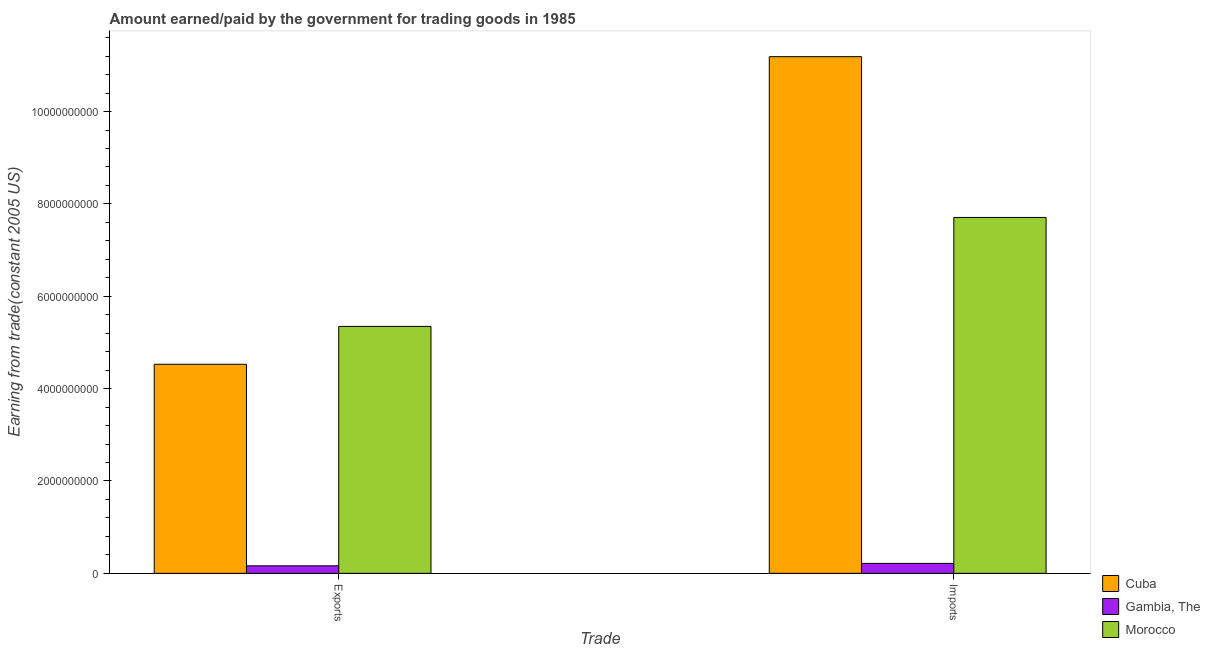How many different coloured bars are there?
Your answer should be compact. 3. Are the number of bars per tick equal to the number of legend labels?
Keep it short and to the point. Yes. Are the number of bars on each tick of the X-axis equal?
Your answer should be compact. Yes. How many bars are there on the 1st tick from the right?
Your answer should be compact. 3. What is the label of the 1st group of bars from the left?
Your response must be concise. Exports. What is the amount paid for imports in Gambia, The?
Keep it short and to the point. 2.15e+08. Across all countries, what is the maximum amount earned from exports?
Provide a short and direct response. 5.35e+09. Across all countries, what is the minimum amount earned from exports?
Your answer should be very brief. 1.63e+08. In which country was the amount earned from exports maximum?
Your answer should be very brief. Morocco. In which country was the amount earned from exports minimum?
Your answer should be compact. Gambia, The. What is the total amount paid for imports in the graph?
Give a very brief answer. 1.91e+1. What is the difference between the amount earned from exports in Cuba and that in Gambia, The?
Provide a short and direct response. 4.36e+09. What is the difference between the amount earned from exports in Cuba and the amount paid for imports in Gambia, The?
Keep it short and to the point. 4.31e+09. What is the average amount paid for imports per country?
Make the answer very short. 6.37e+09. What is the difference between the amount earned from exports and amount paid for imports in Gambia, The?
Offer a terse response. -5.21e+07. In how many countries, is the amount paid for imports greater than 8400000000 US$?
Offer a very short reply. 1. What is the ratio of the amount earned from exports in Cuba to that in Morocco?
Give a very brief answer. 0.85. In how many countries, is the amount earned from exports greater than the average amount earned from exports taken over all countries?
Offer a terse response. 2. What does the 3rd bar from the left in Imports represents?
Make the answer very short. Morocco. What does the 3rd bar from the right in Imports represents?
Provide a succinct answer. Cuba. Are all the bars in the graph horizontal?
Provide a short and direct response. No. Where does the legend appear in the graph?
Offer a terse response. Bottom right. How many legend labels are there?
Keep it short and to the point. 3. What is the title of the graph?
Provide a short and direct response. Amount earned/paid by the government for trading goods in 1985. What is the label or title of the X-axis?
Keep it short and to the point. Trade. What is the label or title of the Y-axis?
Ensure brevity in your answer.  Earning from trade(constant 2005 US). What is the Earning from trade(constant 2005 US) in Cuba in Exports?
Your response must be concise. 4.53e+09. What is the Earning from trade(constant 2005 US) in Gambia, The in Exports?
Keep it short and to the point. 1.63e+08. What is the Earning from trade(constant 2005 US) of Morocco in Exports?
Keep it short and to the point. 5.35e+09. What is the Earning from trade(constant 2005 US) in Cuba in Imports?
Make the answer very short. 1.12e+1. What is the Earning from trade(constant 2005 US) of Gambia, The in Imports?
Make the answer very short. 2.15e+08. What is the Earning from trade(constant 2005 US) in Morocco in Imports?
Provide a succinct answer. 7.71e+09. Across all Trade, what is the maximum Earning from trade(constant 2005 US) of Cuba?
Your answer should be very brief. 1.12e+1. Across all Trade, what is the maximum Earning from trade(constant 2005 US) of Gambia, The?
Provide a succinct answer. 2.15e+08. Across all Trade, what is the maximum Earning from trade(constant 2005 US) of Morocco?
Make the answer very short. 7.71e+09. Across all Trade, what is the minimum Earning from trade(constant 2005 US) in Cuba?
Keep it short and to the point. 4.53e+09. Across all Trade, what is the minimum Earning from trade(constant 2005 US) in Gambia, The?
Offer a very short reply. 1.63e+08. Across all Trade, what is the minimum Earning from trade(constant 2005 US) in Morocco?
Your answer should be very brief. 5.35e+09. What is the total Earning from trade(constant 2005 US) of Cuba in the graph?
Ensure brevity in your answer.  1.57e+1. What is the total Earning from trade(constant 2005 US) in Gambia, The in the graph?
Offer a very short reply. 3.78e+08. What is the total Earning from trade(constant 2005 US) in Morocco in the graph?
Provide a short and direct response. 1.31e+1. What is the difference between the Earning from trade(constant 2005 US) of Cuba in Exports and that in Imports?
Your answer should be very brief. -6.66e+09. What is the difference between the Earning from trade(constant 2005 US) in Gambia, The in Exports and that in Imports?
Make the answer very short. -5.21e+07. What is the difference between the Earning from trade(constant 2005 US) in Morocco in Exports and that in Imports?
Provide a succinct answer. -2.36e+09. What is the difference between the Earning from trade(constant 2005 US) in Cuba in Exports and the Earning from trade(constant 2005 US) in Gambia, The in Imports?
Make the answer very short. 4.31e+09. What is the difference between the Earning from trade(constant 2005 US) in Cuba in Exports and the Earning from trade(constant 2005 US) in Morocco in Imports?
Make the answer very short. -3.18e+09. What is the difference between the Earning from trade(constant 2005 US) of Gambia, The in Exports and the Earning from trade(constant 2005 US) of Morocco in Imports?
Ensure brevity in your answer.  -7.54e+09. What is the average Earning from trade(constant 2005 US) in Cuba per Trade?
Offer a very short reply. 7.86e+09. What is the average Earning from trade(constant 2005 US) of Gambia, The per Trade?
Ensure brevity in your answer.  1.89e+08. What is the average Earning from trade(constant 2005 US) of Morocco per Trade?
Make the answer very short. 6.53e+09. What is the difference between the Earning from trade(constant 2005 US) of Cuba and Earning from trade(constant 2005 US) of Gambia, The in Exports?
Provide a short and direct response. 4.36e+09. What is the difference between the Earning from trade(constant 2005 US) of Cuba and Earning from trade(constant 2005 US) of Morocco in Exports?
Provide a short and direct response. -8.20e+08. What is the difference between the Earning from trade(constant 2005 US) in Gambia, The and Earning from trade(constant 2005 US) in Morocco in Exports?
Keep it short and to the point. -5.18e+09. What is the difference between the Earning from trade(constant 2005 US) in Cuba and Earning from trade(constant 2005 US) in Gambia, The in Imports?
Keep it short and to the point. 1.10e+1. What is the difference between the Earning from trade(constant 2005 US) of Cuba and Earning from trade(constant 2005 US) of Morocco in Imports?
Offer a very short reply. 3.48e+09. What is the difference between the Earning from trade(constant 2005 US) of Gambia, The and Earning from trade(constant 2005 US) of Morocco in Imports?
Give a very brief answer. -7.49e+09. What is the ratio of the Earning from trade(constant 2005 US) in Cuba in Exports to that in Imports?
Your answer should be compact. 0.4. What is the ratio of the Earning from trade(constant 2005 US) in Gambia, The in Exports to that in Imports?
Make the answer very short. 0.76. What is the ratio of the Earning from trade(constant 2005 US) in Morocco in Exports to that in Imports?
Provide a succinct answer. 0.69. What is the difference between the highest and the second highest Earning from trade(constant 2005 US) of Cuba?
Make the answer very short. 6.66e+09. What is the difference between the highest and the second highest Earning from trade(constant 2005 US) in Gambia, The?
Offer a terse response. 5.21e+07. What is the difference between the highest and the second highest Earning from trade(constant 2005 US) of Morocco?
Provide a succinct answer. 2.36e+09. What is the difference between the highest and the lowest Earning from trade(constant 2005 US) in Cuba?
Ensure brevity in your answer.  6.66e+09. What is the difference between the highest and the lowest Earning from trade(constant 2005 US) in Gambia, The?
Make the answer very short. 5.21e+07. What is the difference between the highest and the lowest Earning from trade(constant 2005 US) in Morocco?
Your answer should be compact. 2.36e+09. 